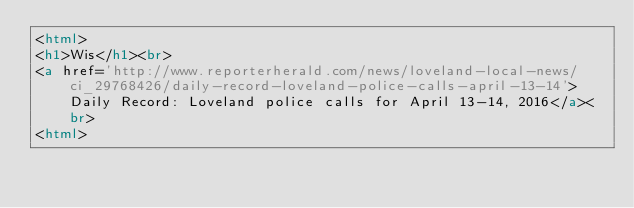<code> <loc_0><loc_0><loc_500><loc_500><_HTML_><html>
<h1>Wis</h1><br>
<a href='http://www.reporterherald.com/news/loveland-local-news/ci_29768426/daily-record-loveland-police-calls-april-13-14'>Daily Record: Loveland police calls for April 13-14, 2016</a><br>
<html></code> 